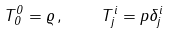<formula> <loc_0><loc_0><loc_500><loc_500>T _ { 0 } ^ { 0 } = \varrho \, , \quad T _ { j } ^ { i } = p \delta _ { j } ^ { i }</formula> 